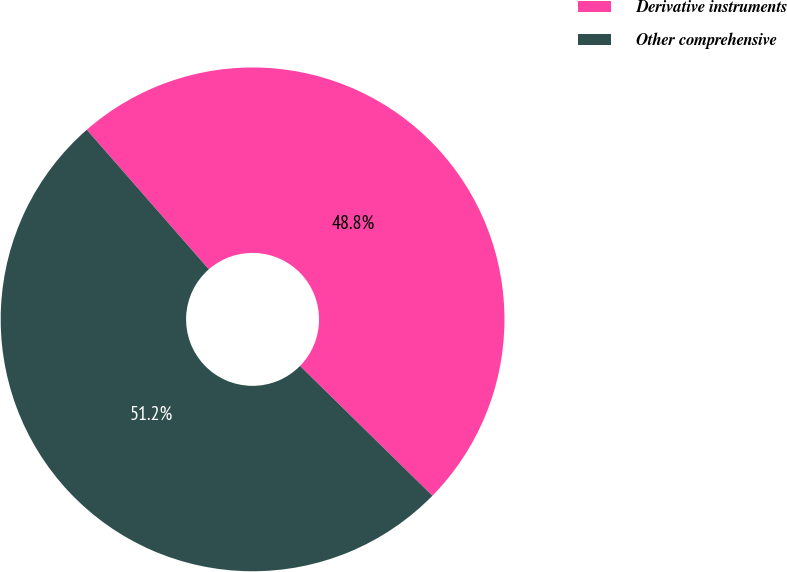<chart> <loc_0><loc_0><loc_500><loc_500><pie_chart><fcel>Derivative instruments<fcel>Other comprehensive<nl><fcel>48.78%<fcel>51.22%<nl></chart> 